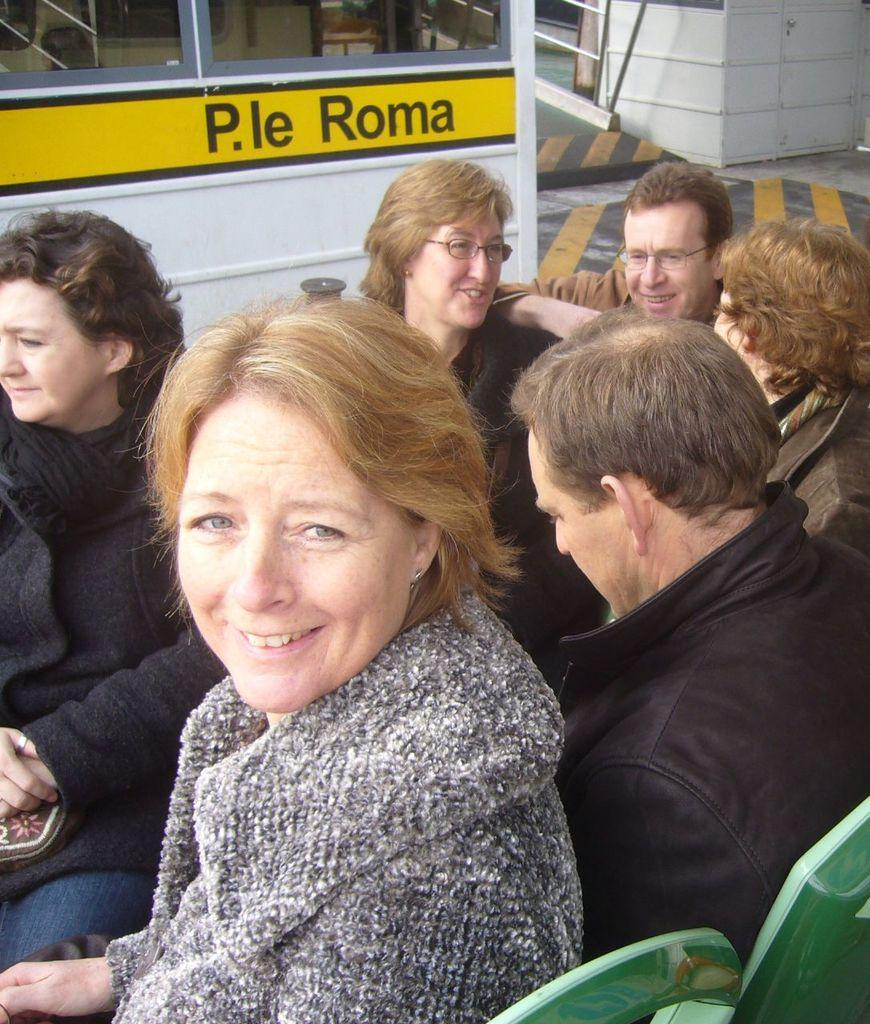What are the people in the image wearing? The persons in the image are wearing clothes. What type of structures can be seen at the top of the image? There are cabins at the top of the image. What type of furniture is located in the bottom right of the image? There are chairs in the bottom right of the image. Can you see any muscles in the image? There are no muscles visible in the image; it features persons wearing clothes and other objects. 